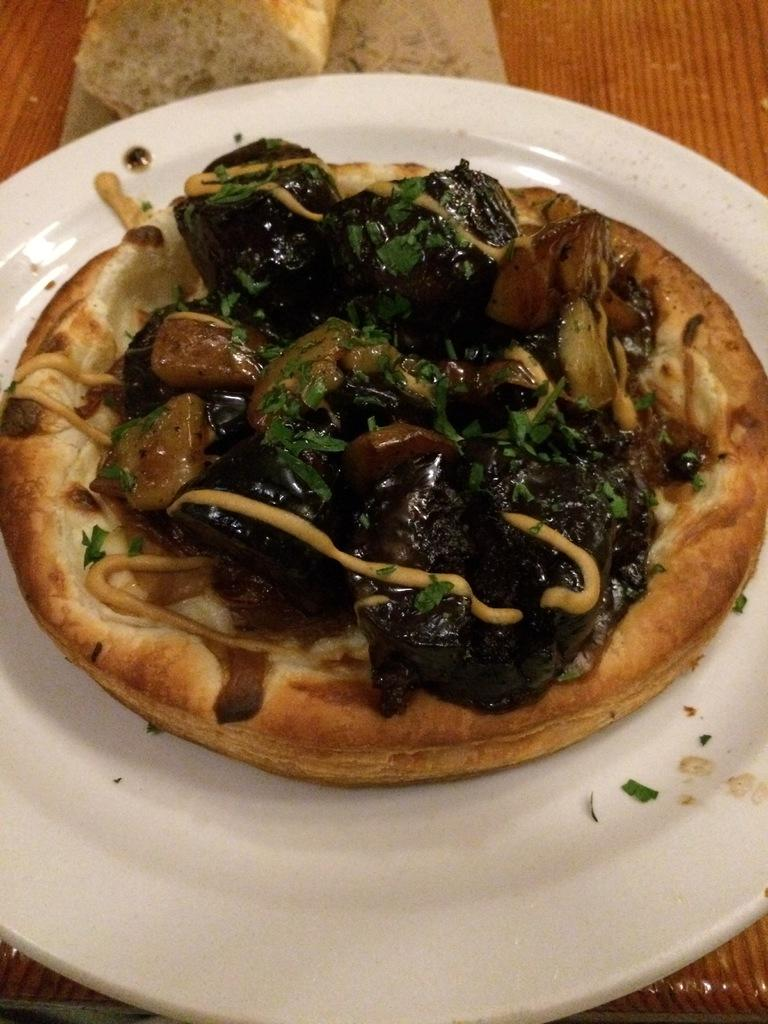What is on the plate that is visible in the image? There is a plate containing food in the image. What is the surface that the plate is placed on? The plate is placed on a wooden surface. What type of food can be seen at the top of the image? There is bread visible at the top of the image. What color is the coat hanging on the thread in the image? There is no coat or thread present in the image. 